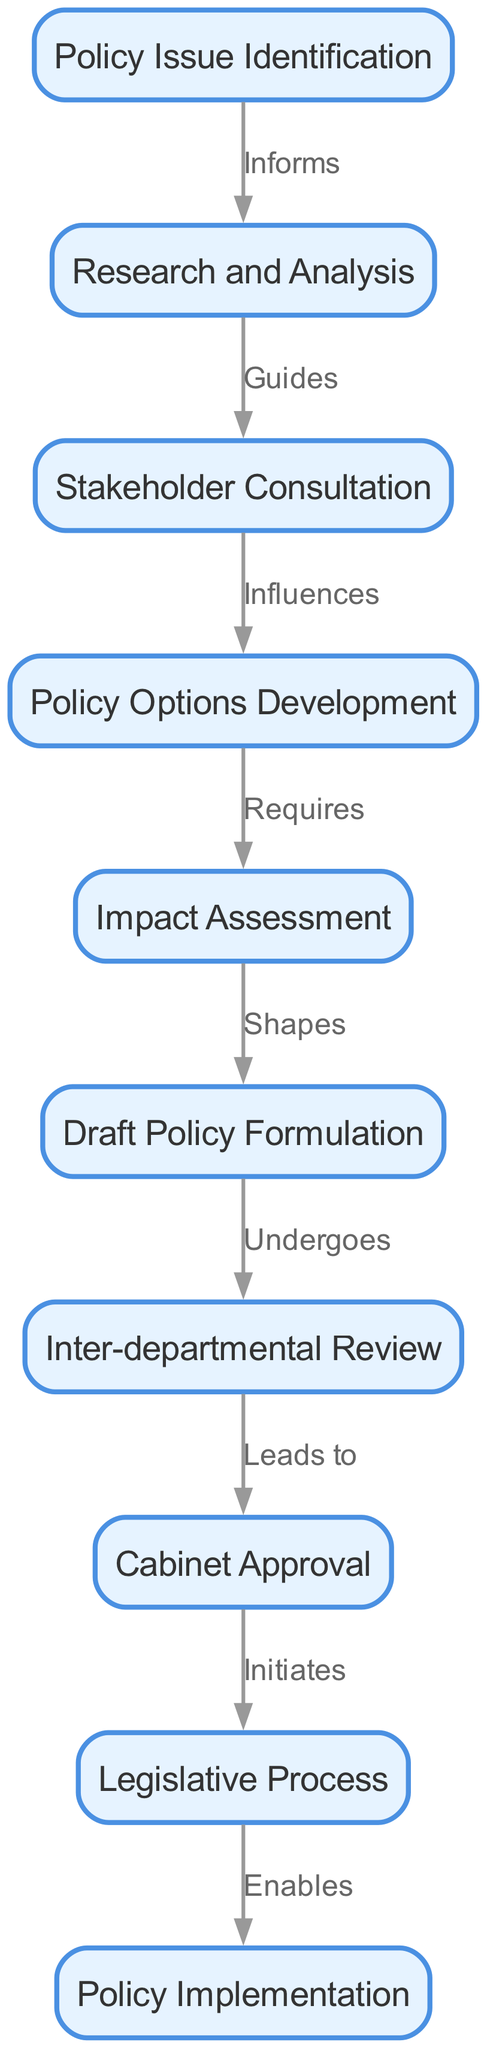What is the first step in the policy formulation process? The diagram indicates that the first node is "Policy Issue Identification," which is where the process begins.
Answer: Policy Issue Identification How many nodes are in the diagram? By counting each unique node listed in the data, there are a total of 10 distinct nodes representing various stages of the policy formulation process.
Answer: 10 What relationship does "Research and Analysis" have with "Stakeholder Consultation"? The diagram shows that "Research and Analysis" guides "Stakeholder Consultation," indicating that the findings of the research shape the discussions with stakeholders.
Answer: Guides Which step follows "Draft Policy Formulation"? According to the diagram, "Inter-departmental Review" is the step that comes after "Draft Policy Formulation," illustrating a transition between forming a draft and reviewing it departmentally.
Answer: Inter-departmental Review Which node leads to "Cabinet Approval"? The diagram specifies that "Inter-departmental Review" leads to "Cabinet Approval," showing a direct connection indicating that the review process must be completed before moving to cabinet for approval.
Answer: Inter-departmental Review What does "Impact Assessment" require? The diagram shows that "Impact Assessment" requires "Policy Options Development," indicating that an analysis of potential impacts can only occur after various policy options are identified and formulated.
Answer: Policy Options Development How many edges are present in the diagram? By counting each connection or edge between the nodes, there are a total of 9 edges illustrating the various relationships and transitions between the stages of policy formulation.
Answer: 9 What does "Legislative Process" enable? The diagram identifies that "Legislative Process" enables "Policy Implementation," indicating that through the successful passage of legislation, policies can be implemented effectively.
Answer: Policy Implementation What influences the development of policy options? "Stakeholder Consultation" influences the development of policy options, as indicated in the diagram, showing that input from stakeholders shapes and informs the options considered in policy-making.
Answer: Influences 